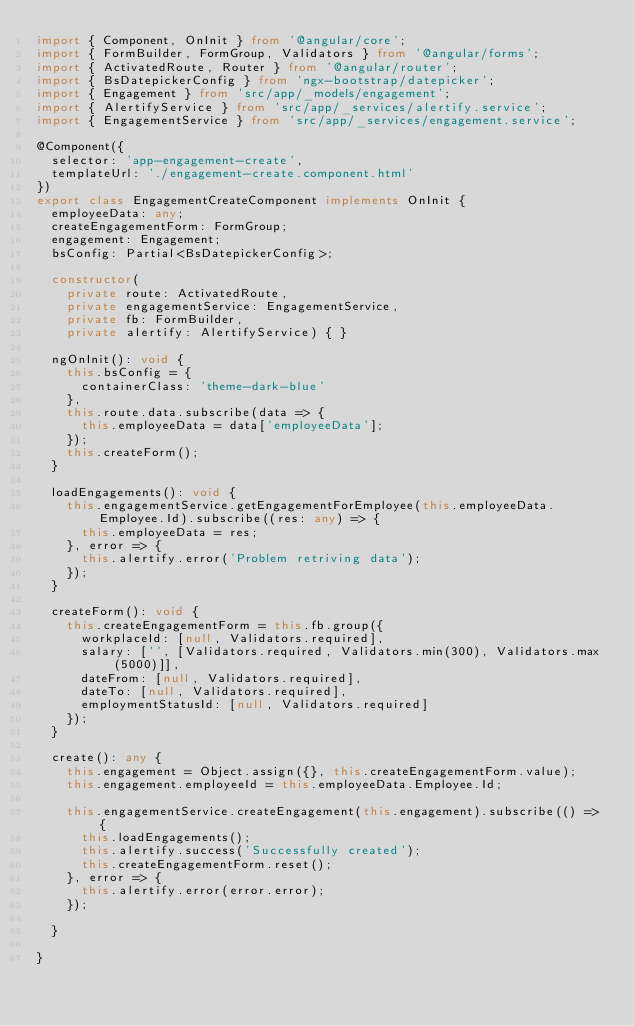<code> <loc_0><loc_0><loc_500><loc_500><_TypeScript_>import { Component, OnInit } from '@angular/core';
import { FormBuilder, FormGroup, Validators } from '@angular/forms';
import { ActivatedRoute, Router } from '@angular/router';
import { BsDatepickerConfig } from 'ngx-bootstrap/datepicker';
import { Engagement } from 'src/app/_models/engagement';
import { AlertifyService } from 'src/app/_services/alertify.service';
import { EngagementService } from 'src/app/_services/engagement.service';

@Component({
  selector: 'app-engagement-create',
  templateUrl: './engagement-create.component.html'
})
export class EngagementCreateComponent implements OnInit {
  employeeData: any;
  createEngagementForm: FormGroup;
  engagement: Engagement;
  bsConfig: Partial<BsDatepickerConfig>;

  constructor(
    private route: ActivatedRoute,
    private engagementService: EngagementService,
    private fb: FormBuilder,
    private alertify: AlertifyService) { }

  ngOnInit(): void {
    this.bsConfig = {
      containerClass: 'theme-dark-blue'
    },
    this.route.data.subscribe(data => {
      this.employeeData = data['employeeData'];
    });
    this.createForm();
  }

  loadEngagements(): void {
    this.engagementService.getEngagementForEmployee(this.employeeData.Employee.Id).subscribe((res: any) => {
      this.employeeData = res;
    }, error => {
      this.alertify.error('Problem retriving data');
    });
  }

  createForm(): void {
    this.createEngagementForm = this.fb.group({
      workplaceId: [null, Validators.required],
      salary: ['', [Validators.required, Validators.min(300), Validators.max(5000)]],
      dateFrom: [null, Validators.required],
      dateTo: [null, Validators.required],
      employmentStatusId: [null, Validators.required]
    });
  }

  create(): any {
    this.engagement = Object.assign({}, this.createEngagementForm.value);
    this.engagement.employeeId = this.employeeData.Employee.Id;

    this.engagementService.createEngagement(this.engagement).subscribe(() => {
      this.loadEngagements();
      this.alertify.success('Successfully created');
      this.createEngagementForm.reset();
    }, error => {
      this.alertify.error(error.error);
    });

  }

}
</code> 